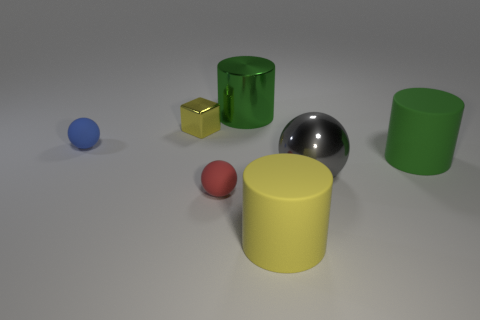Subtract all shiny spheres. How many spheres are left? 2 Add 1 red things. How many objects exist? 8 Subtract all gray balls. How many balls are left? 2 Subtract 1 cylinders. How many cylinders are left? 2 Subtract all blocks. How many objects are left? 6 Subtract all brown cylinders. How many green blocks are left? 0 Subtract all blue matte objects. Subtract all yellow cylinders. How many objects are left? 5 Add 2 tiny spheres. How many tiny spheres are left? 4 Add 1 tiny brown matte balls. How many tiny brown matte balls exist? 1 Subtract 0 green cubes. How many objects are left? 7 